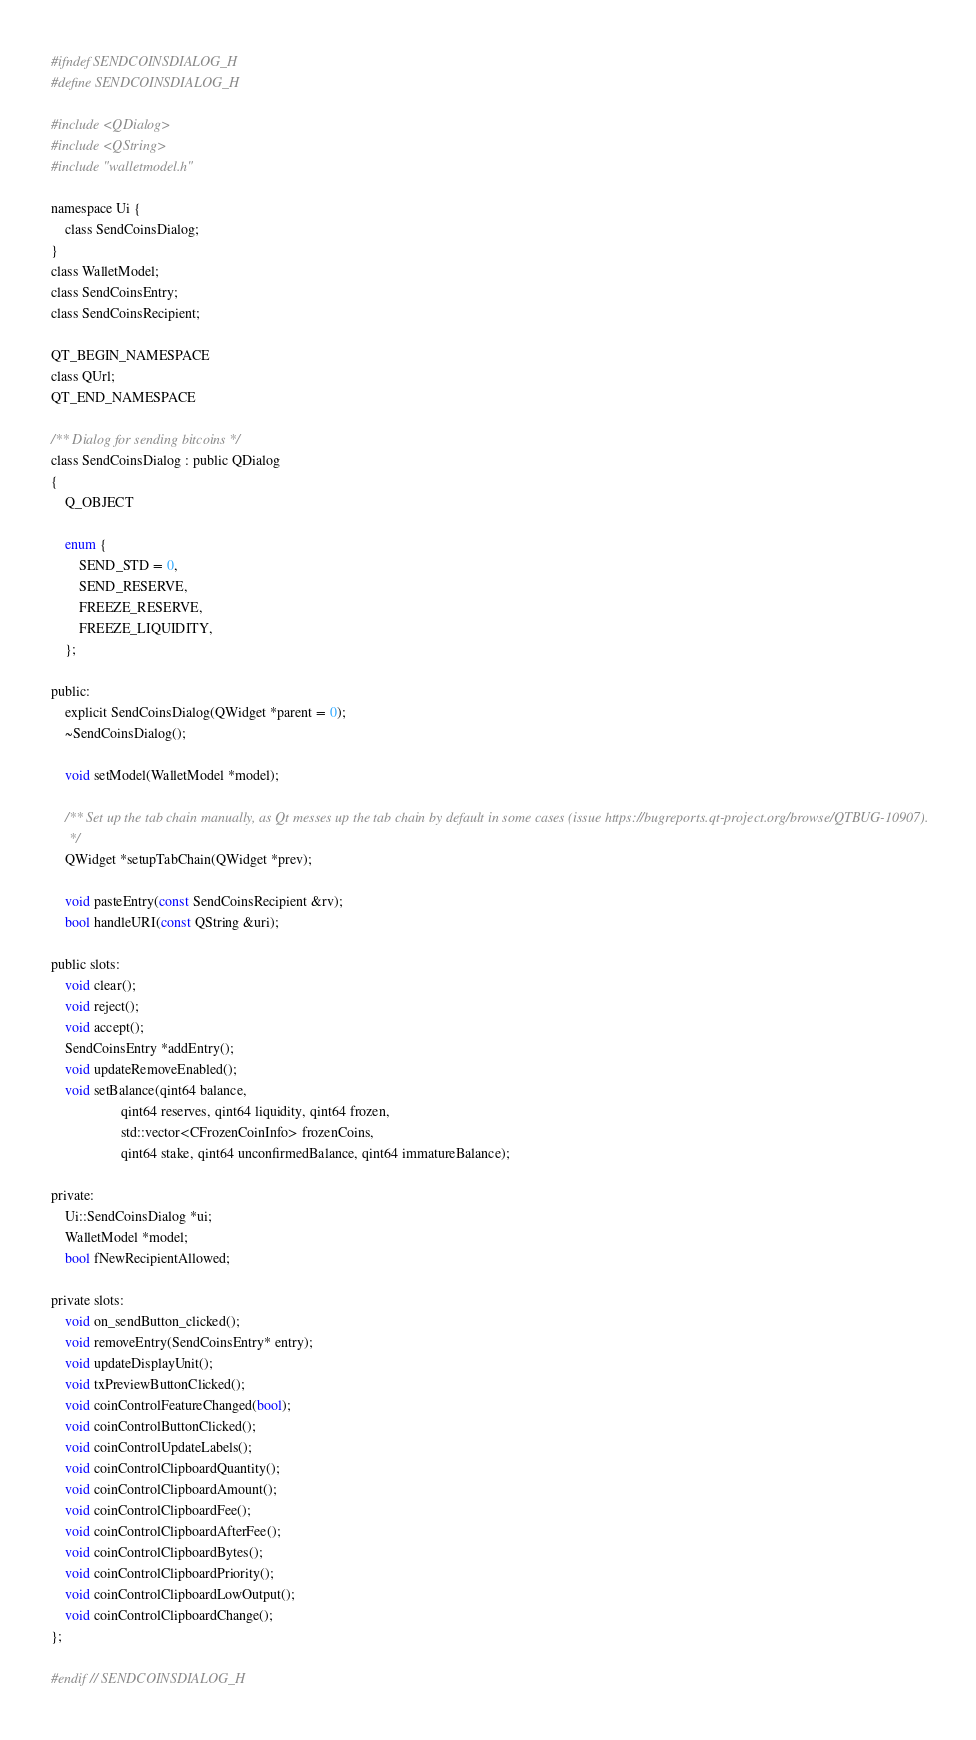Convert code to text. <code><loc_0><loc_0><loc_500><loc_500><_C_>#ifndef SENDCOINSDIALOG_H
#define SENDCOINSDIALOG_H

#include <QDialog>
#include <QString>
#include "walletmodel.h"

namespace Ui {
    class SendCoinsDialog;
}
class WalletModel;
class SendCoinsEntry;
class SendCoinsRecipient;

QT_BEGIN_NAMESPACE
class QUrl;
QT_END_NAMESPACE

/** Dialog for sending bitcoins */
class SendCoinsDialog : public QDialog
{
    Q_OBJECT

    enum {
        SEND_STD = 0,
        SEND_RESERVE,
        FREEZE_RESERVE,
        FREEZE_LIQUIDITY,
    };
    
public:
    explicit SendCoinsDialog(QWidget *parent = 0);
    ~SendCoinsDialog();

    void setModel(WalletModel *model);

    /** Set up the tab chain manually, as Qt messes up the tab chain by default in some cases (issue https://bugreports.qt-project.org/browse/QTBUG-10907).
     */
    QWidget *setupTabChain(QWidget *prev);

    void pasteEntry(const SendCoinsRecipient &rv);
    bool handleURI(const QString &uri);

public slots:
    void clear();
    void reject();
    void accept();
    SendCoinsEntry *addEntry();
    void updateRemoveEnabled();
    void setBalance(qint64 balance, 
                    qint64 reserves, qint64 liquidity, qint64 frozen,
                    std::vector<CFrozenCoinInfo> frozenCoins,
                    qint64 stake, qint64 unconfirmedBalance, qint64 immatureBalance);

private:
    Ui::SendCoinsDialog *ui;
    WalletModel *model;
    bool fNewRecipientAllowed;

private slots:
    void on_sendButton_clicked();
    void removeEntry(SendCoinsEntry* entry);
    void updateDisplayUnit();
    void txPreviewButtonClicked();
    void coinControlFeatureChanged(bool);
    void coinControlButtonClicked();
    void coinControlUpdateLabels();
    void coinControlClipboardQuantity();
    void coinControlClipboardAmount();
    void coinControlClipboardFee();
    void coinControlClipboardAfterFee();
    void coinControlClipboardBytes();
    void coinControlClipboardPriority();
    void coinControlClipboardLowOutput();
    void coinControlClipboardChange();
};

#endif // SENDCOINSDIALOG_H
</code> 